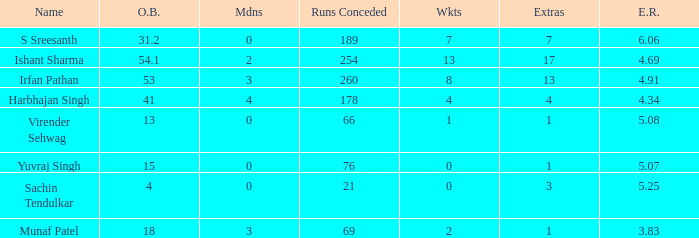Identify the wickets for 15 overs bowled. 0.0. 